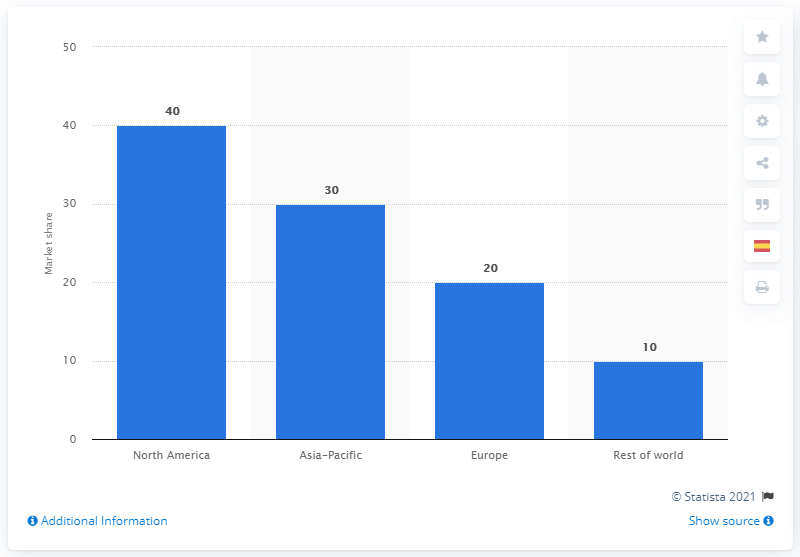Indicate a few pertinent items in this graphic. In 2020, it is estimated that North America will account for approximately 40% of the total world's market volume. 